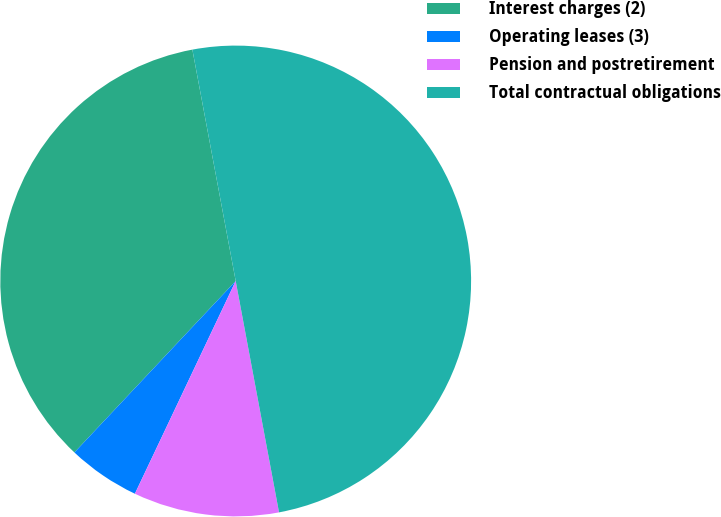Convert chart to OTSL. <chart><loc_0><loc_0><loc_500><loc_500><pie_chart><fcel>Interest charges (2)<fcel>Operating leases (3)<fcel>Pension and postretirement<fcel>Total contractual obligations<nl><fcel>35.04%<fcel>4.97%<fcel>9.99%<fcel>50.0%<nl></chart> 